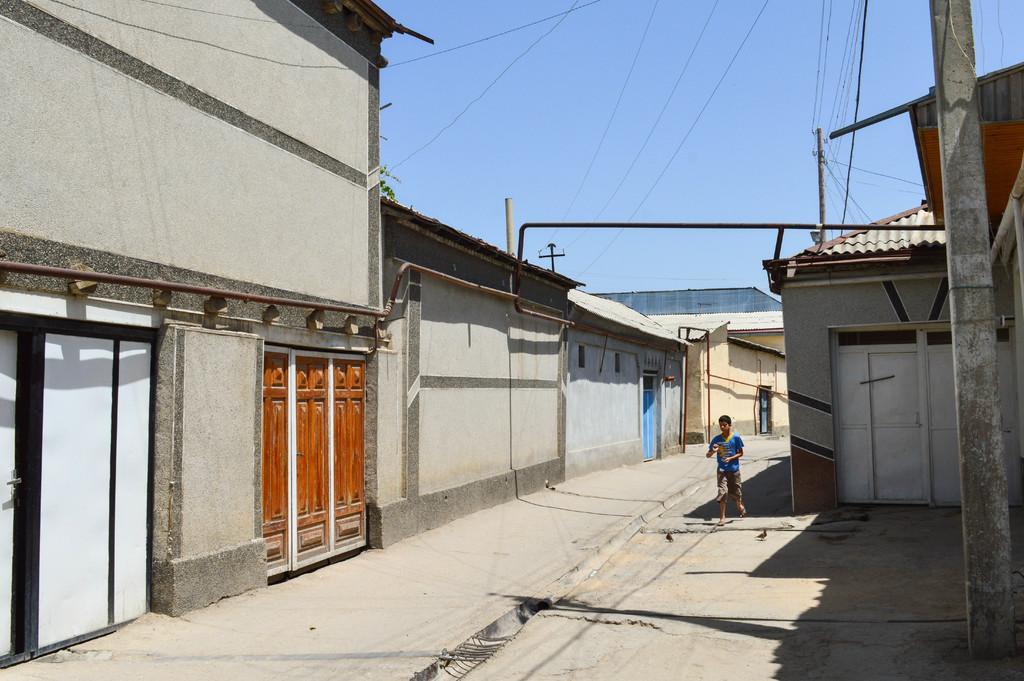Describe this image in one or two sentences. In this image there are buildings and there are poles and there are wires and in the center there is a person running. 